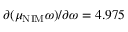<formula> <loc_0><loc_0><loc_500><loc_500>\partial ( \mu _ { N I M } \omega ) / \partial \omega = 4 . 9 7 5</formula> 